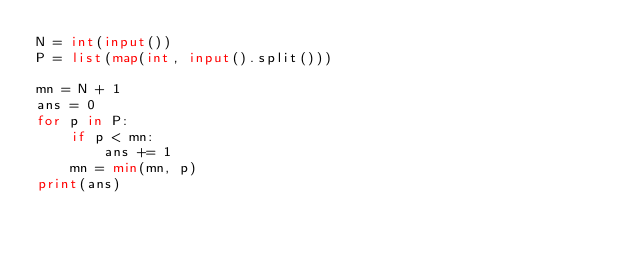<code> <loc_0><loc_0><loc_500><loc_500><_Python_>N = int(input())
P = list(map(int, input().split()))

mn = N + 1
ans = 0
for p in P:
    if p < mn:
        ans += 1
    mn = min(mn, p)
print(ans)</code> 